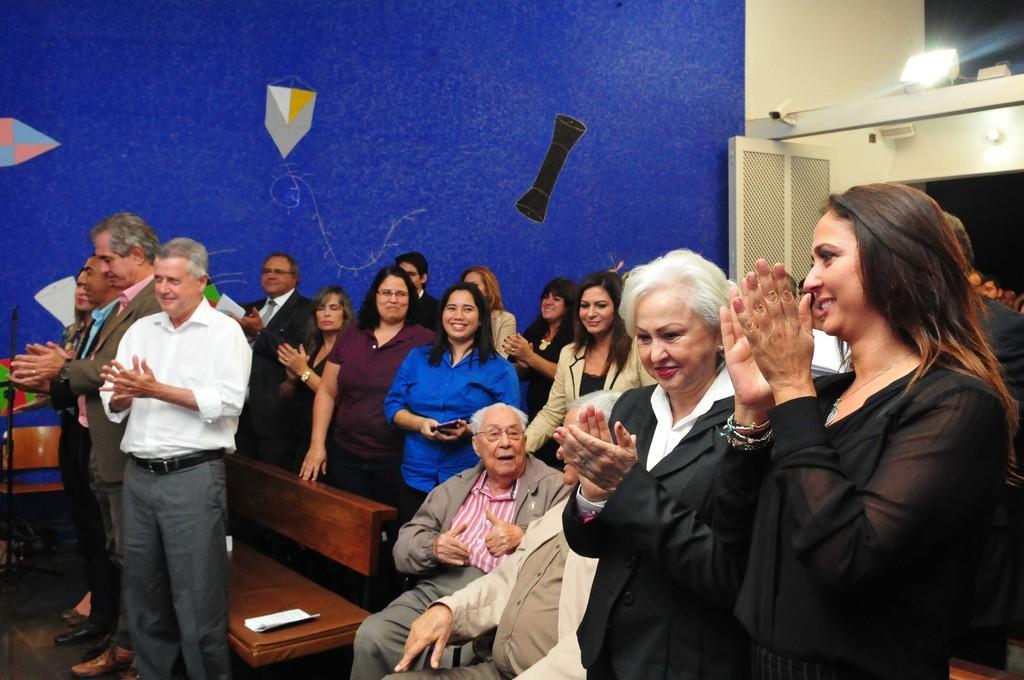Can you describe this image briefly? In this image there are group of people standing, two persons sitting, there is a bench, a chair, painting on the wall, and there is a light. 